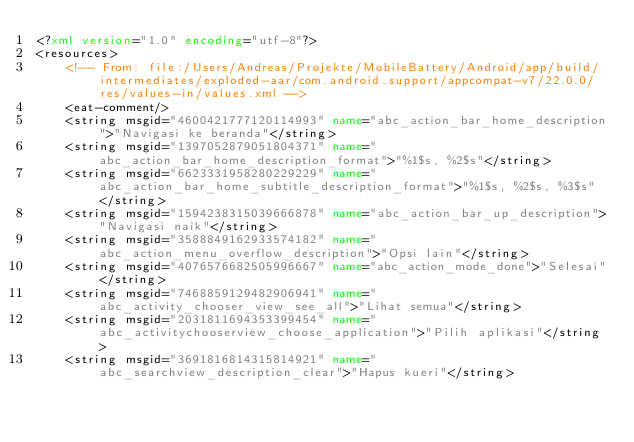Convert code to text. <code><loc_0><loc_0><loc_500><loc_500><_XML_><?xml version="1.0" encoding="utf-8"?>
<resources>
    <!-- From: file:/Users/Andreas/Projekte/MobileBattery/Android/app/build/intermediates/exploded-aar/com.android.support/appcompat-v7/22.0.0/res/values-in/values.xml -->
    <eat-comment/>
    <string msgid="4600421777120114993" name="abc_action_bar_home_description">"Navigasi ke beranda"</string>
    <string msgid="1397052879051804371" name="abc_action_bar_home_description_format">"%1$s, %2$s"</string>
    <string msgid="6623331958280229229" name="abc_action_bar_home_subtitle_description_format">"%1$s, %2$s, %3$s"</string>
    <string msgid="1594238315039666878" name="abc_action_bar_up_description">"Navigasi naik"</string>
    <string msgid="3588849162933574182" name="abc_action_menu_overflow_description">"Opsi lain"</string>
    <string msgid="4076576682505996667" name="abc_action_mode_done">"Selesai"</string>
    <string msgid="7468859129482906941" name="abc_activity_chooser_view_see_all">"Lihat semua"</string>
    <string msgid="2031811694353399454" name="abc_activitychooserview_choose_application">"Pilih aplikasi"</string>
    <string msgid="3691816814315814921" name="abc_searchview_description_clear">"Hapus kueri"</string></code> 